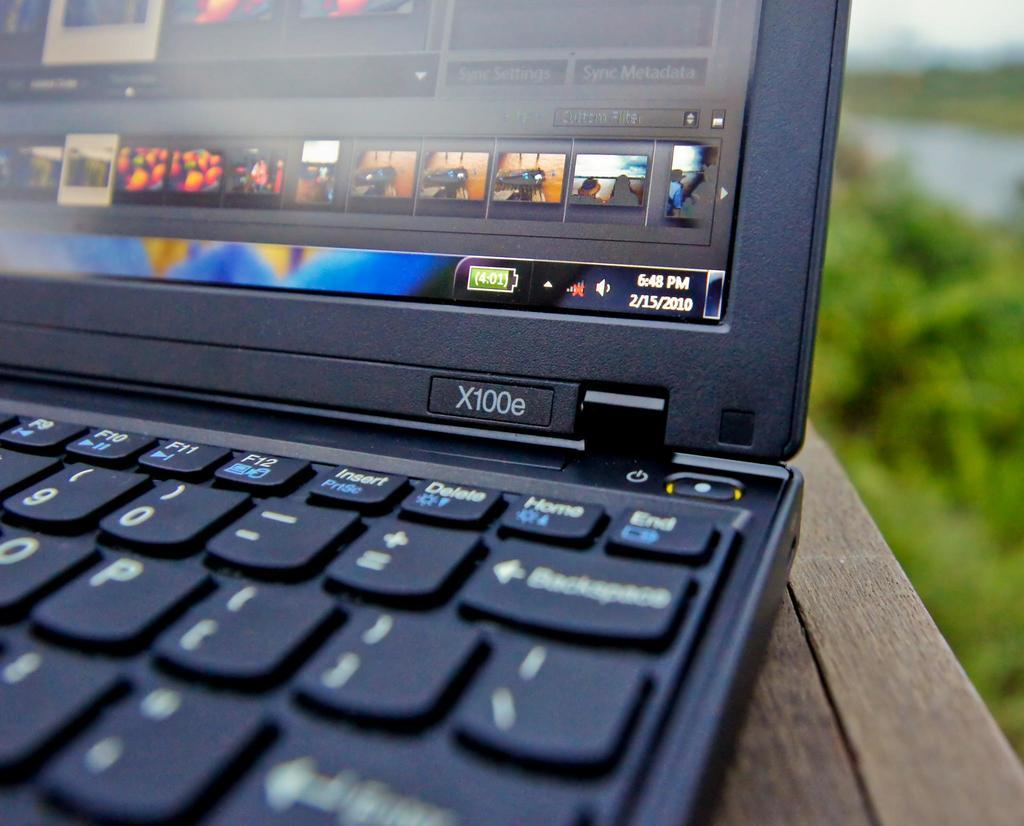<image>
Render a clear and concise summary of the photo. A laptop model X100e is open on a table outdoors. 